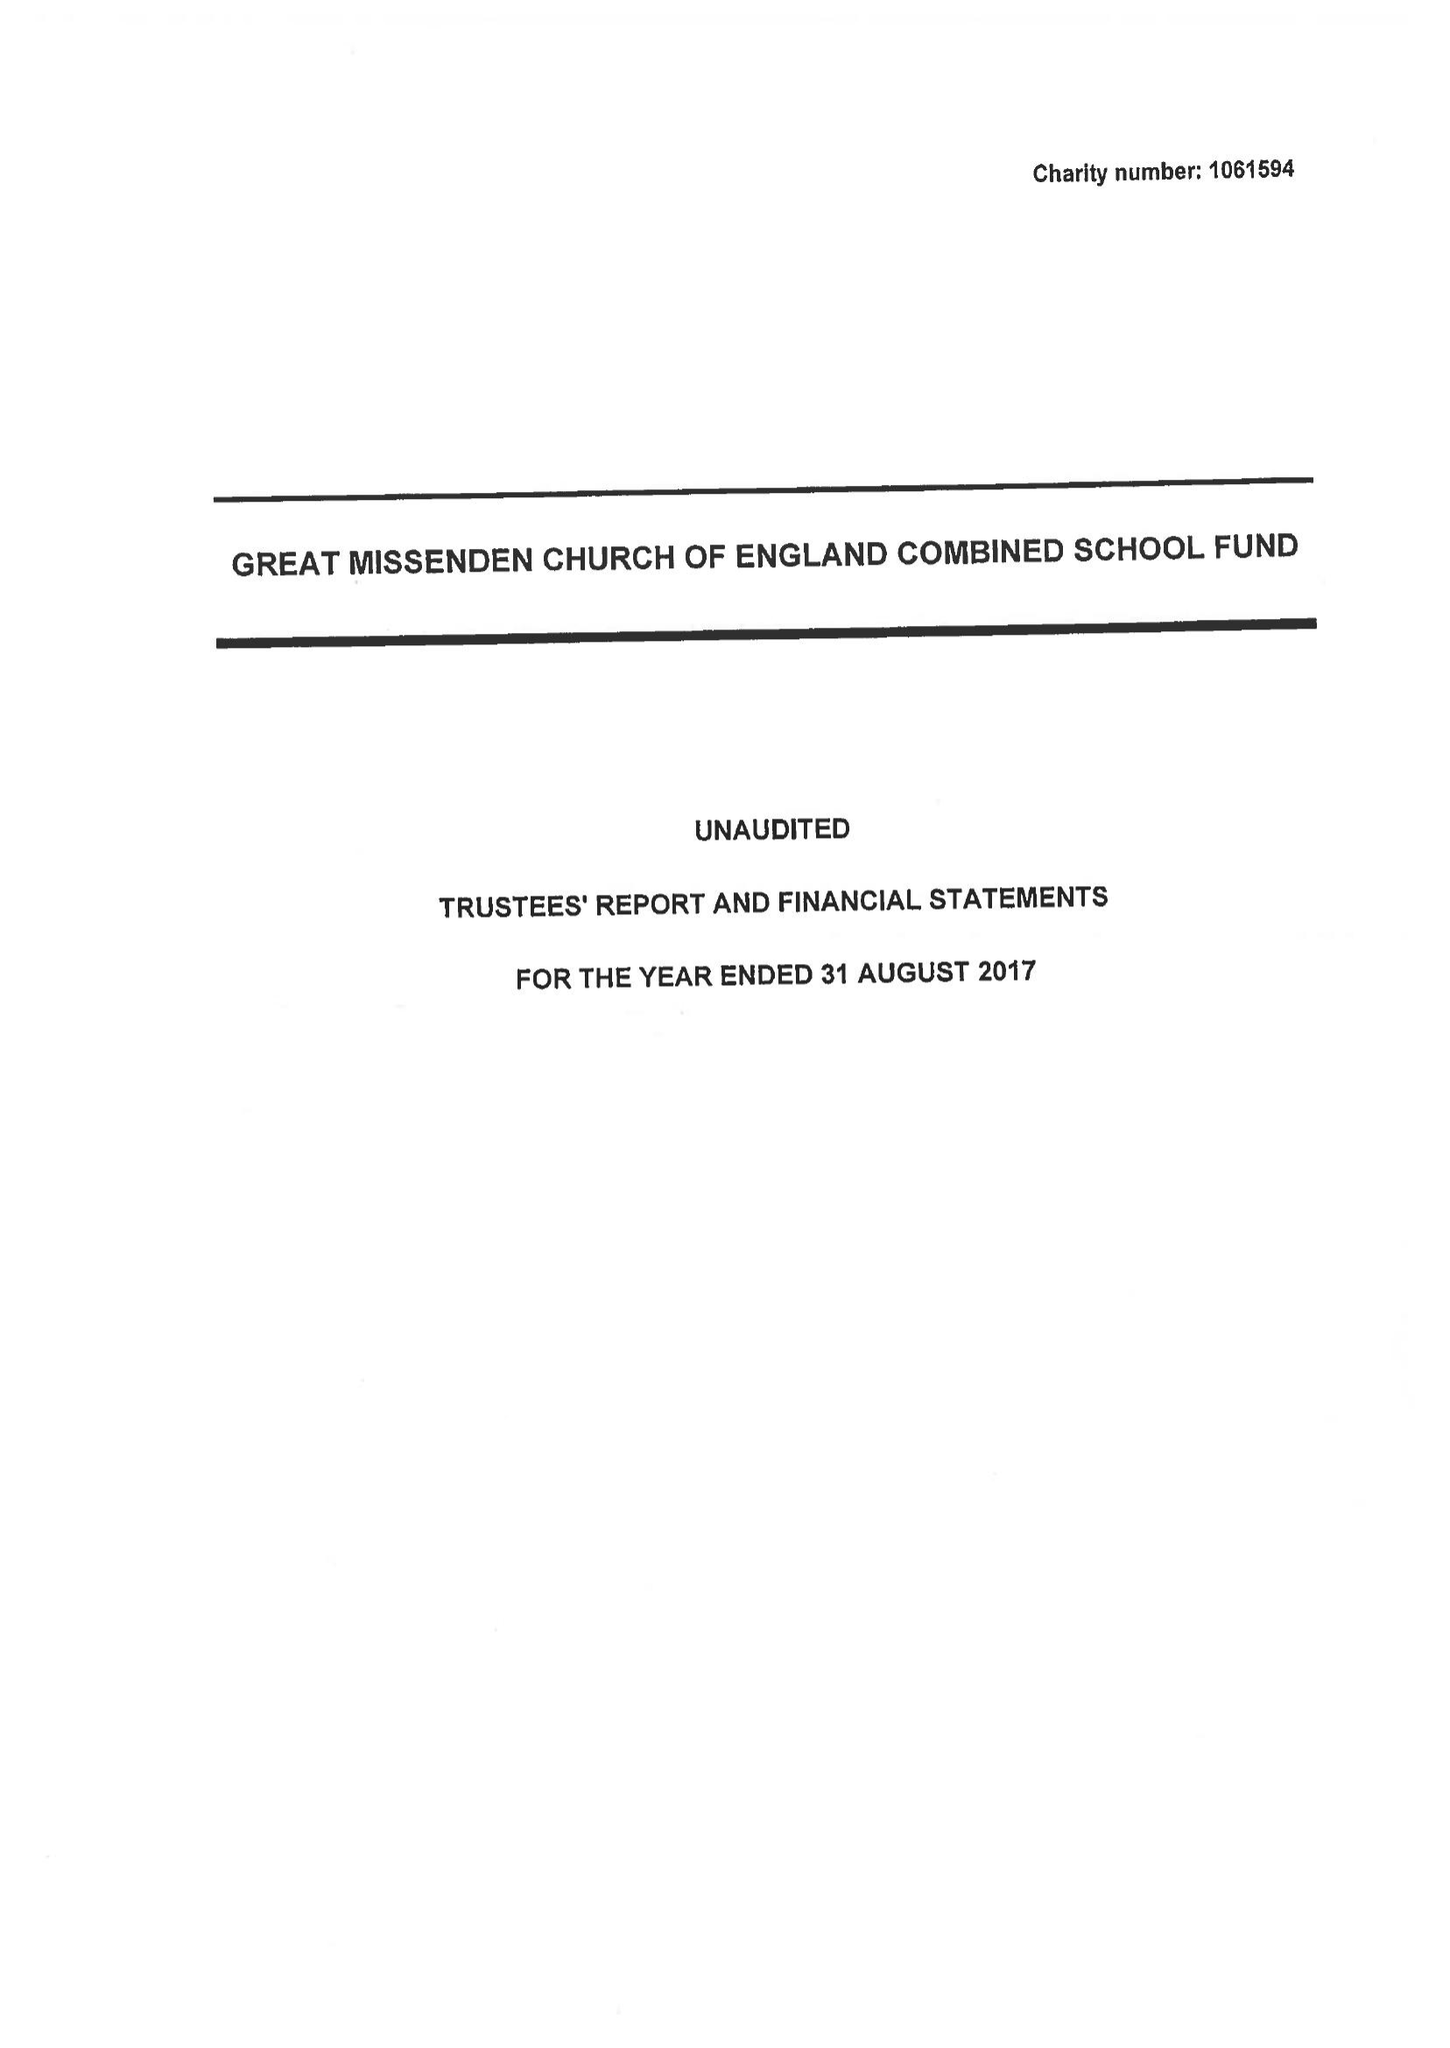What is the value for the charity_name?
Answer the question using a single word or phrase. Great Missenden C Of E Combined School Fund 